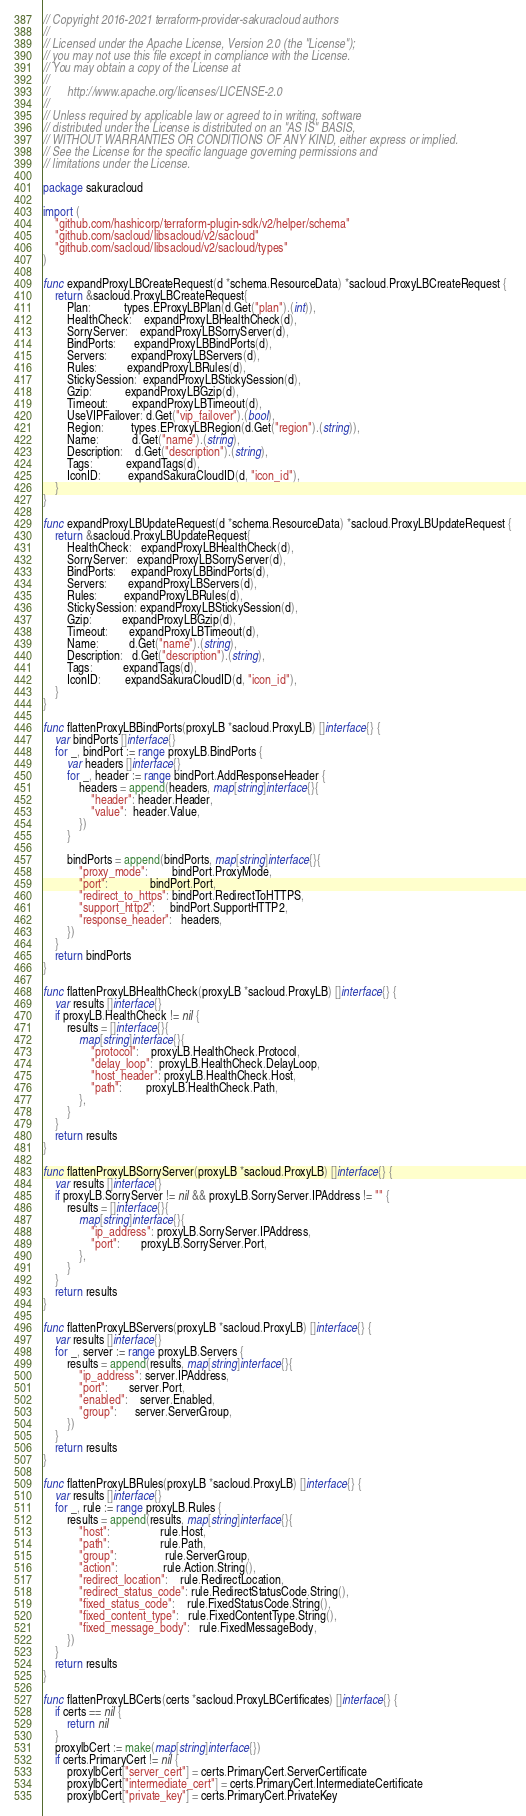<code> <loc_0><loc_0><loc_500><loc_500><_Go_>// Copyright 2016-2021 terraform-provider-sakuracloud authors
//
// Licensed under the Apache License, Version 2.0 (the "License");
// you may not use this file except in compliance with the License.
// You may obtain a copy of the License at
//
//      http://www.apache.org/licenses/LICENSE-2.0
//
// Unless required by applicable law or agreed to in writing, software
// distributed under the License is distributed on an "AS IS" BASIS,
// WITHOUT WARRANTIES OR CONDITIONS OF ANY KIND, either express or implied.
// See the License for the specific language governing permissions and
// limitations under the License.

package sakuracloud

import (
	"github.com/hashicorp/terraform-plugin-sdk/v2/helper/schema"
	"github.com/sacloud/libsacloud/v2/sacloud"
	"github.com/sacloud/libsacloud/v2/sacloud/types"
)

func expandProxyLBCreateRequest(d *schema.ResourceData) *sacloud.ProxyLBCreateRequest {
	return &sacloud.ProxyLBCreateRequest{
		Plan:           types.EProxyLBPlan(d.Get("plan").(int)),
		HealthCheck:    expandProxyLBHealthCheck(d),
		SorryServer:    expandProxyLBSorryServer(d),
		BindPorts:      expandProxyLBBindPorts(d),
		Servers:        expandProxyLBServers(d),
		Rules:          expandProxyLBRules(d),
		StickySession:  expandProxyLBStickySession(d),
		Gzip:           expandProxyLBGzip(d),
		Timeout:        expandProxyLBTimeout(d),
		UseVIPFailover: d.Get("vip_failover").(bool),
		Region:         types.EProxyLBRegion(d.Get("region").(string)),
		Name:           d.Get("name").(string),
		Description:    d.Get("description").(string),
		Tags:           expandTags(d),
		IconID:         expandSakuraCloudID(d, "icon_id"),
	}
}

func expandProxyLBUpdateRequest(d *schema.ResourceData) *sacloud.ProxyLBUpdateRequest {
	return &sacloud.ProxyLBUpdateRequest{
		HealthCheck:   expandProxyLBHealthCheck(d),
		SorryServer:   expandProxyLBSorryServer(d),
		BindPorts:     expandProxyLBBindPorts(d),
		Servers:       expandProxyLBServers(d),
		Rules:         expandProxyLBRules(d),
		StickySession: expandProxyLBStickySession(d),
		Gzip:          expandProxyLBGzip(d),
		Timeout:       expandProxyLBTimeout(d),
		Name:          d.Get("name").(string),
		Description:   d.Get("description").(string),
		Tags:          expandTags(d),
		IconID:        expandSakuraCloudID(d, "icon_id"),
	}
}

func flattenProxyLBBindPorts(proxyLB *sacloud.ProxyLB) []interface{} {
	var bindPorts []interface{}
	for _, bindPort := range proxyLB.BindPorts {
		var headers []interface{}
		for _, header := range bindPort.AddResponseHeader {
			headers = append(headers, map[string]interface{}{
				"header": header.Header,
				"value":  header.Value,
			})
		}

		bindPorts = append(bindPorts, map[string]interface{}{
			"proxy_mode":        bindPort.ProxyMode,
			"port":              bindPort.Port,
			"redirect_to_https": bindPort.RedirectToHTTPS,
			"support_http2":     bindPort.SupportHTTP2,
			"response_header":   headers,
		})
	}
	return bindPorts
}

func flattenProxyLBHealthCheck(proxyLB *sacloud.ProxyLB) []interface{} {
	var results []interface{}
	if proxyLB.HealthCheck != nil {
		results = []interface{}{
			map[string]interface{}{
				"protocol":    proxyLB.HealthCheck.Protocol,
				"delay_loop":  proxyLB.HealthCheck.DelayLoop,
				"host_header": proxyLB.HealthCheck.Host,
				"path":        proxyLB.HealthCheck.Path,
			},
		}
	}
	return results
}

func flattenProxyLBSorryServer(proxyLB *sacloud.ProxyLB) []interface{} {
	var results []interface{}
	if proxyLB.SorryServer != nil && proxyLB.SorryServer.IPAddress != "" {
		results = []interface{}{
			map[string]interface{}{
				"ip_address": proxyLB.SorryServer.IPAddress,
				"port":       proxyLB.SorryServer.Port,
			},
		}
	}
	return results
}

func flattenProxyLBServers(proxyLB *sacloud.ProxyLB) []interface{} {
	var results []interface{}
	for _, server := range proxyLB.Servers {
		results = append(results, map[string]interface{}{
			"ip_address": server.IPAddress,
			"port":       server.Port,
			"enabled":    server.Enabled,
			"group":      server.ServerGroup,
		})
	}
	return results
}

func flattenProxyLBRules(proxyLB *sacloud.ProxyLB) []interface{} {
	var results []interface{}
	for _, rule := range proxyLB.Rules {
		results = append(results, map[string]interface{}{
			"host":                 rule.Host,
			"path":                 rule.Path,
			"group":                rule.ServerGroup,
			"action":               rule.Action.String(),
			"redirect_location":    rule.RedirectLocation,
			"redirect_status_code": rule.RedirectStatusCode.String(),
			"fixed_status_code":    rule.FixedStatusCode.String(),
			"fixed_content_type":   rule.FixedContentType.String(),
			"fixed_message_body":   rule.FixedMessageBody,
		})
	}
	return results
}

func flattenProxyLBCerts(certs *sacloud.ProxyLBCertificates) []interface{} {
	if certs == nil {
		return nil
	}
	proxylbCert := make(map[string]interface{})
	if certs.PrimaryCert != nil {
		proxylbCert["server_cert"] = certs.PrimaryCert.ServerCertificate
		proxylbCert["intermediate_cert"] = certs.PrimaryCert.IntermediateCertificate
		proxylbCert["private_key"] = certs.PrimaryCert.PrivateKey</code> 